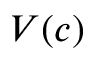<formula> <loc_0><loc_0><loc_500><loc_500>V ( c )</formula> 